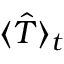Convert formula to latex. <formula><loc_0><loc_0><loc_500><loc_500>\langle \hat { T } \rangle _ { t }</formula> 